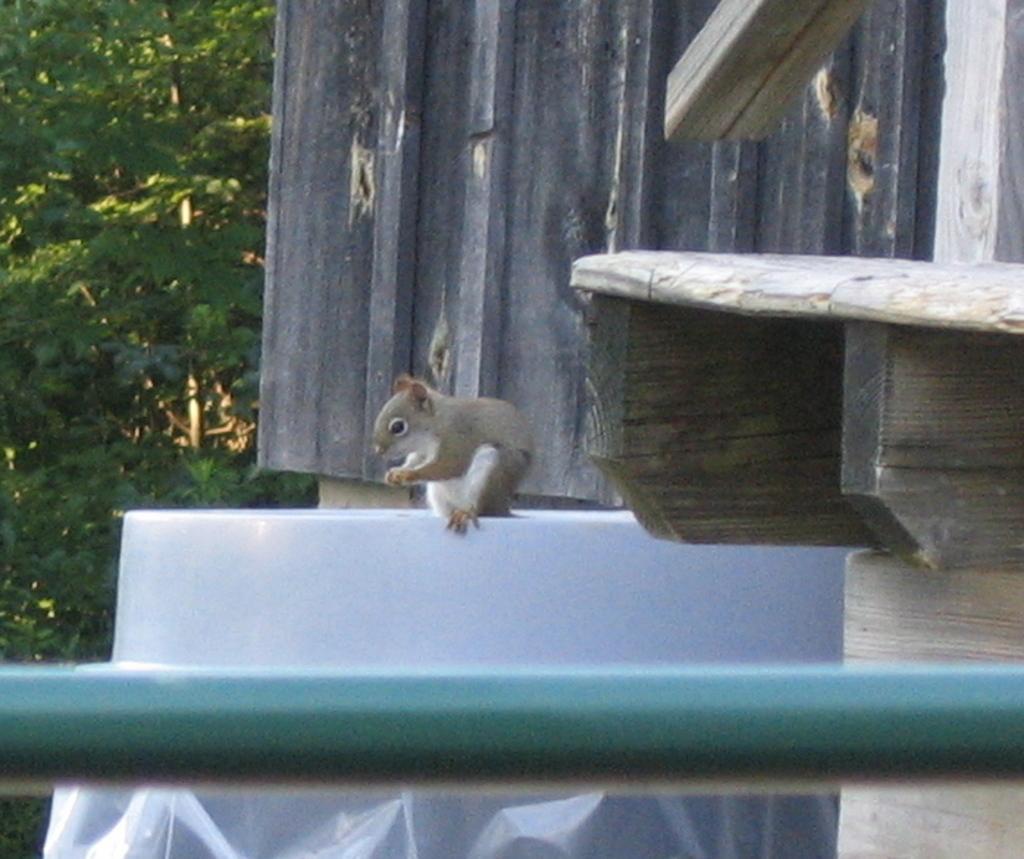Can you describe this image briefly? In this image I can see an animal on the wall. An animal is in white and brown color. In the front I can see the rod. In the background I can see the trees. 